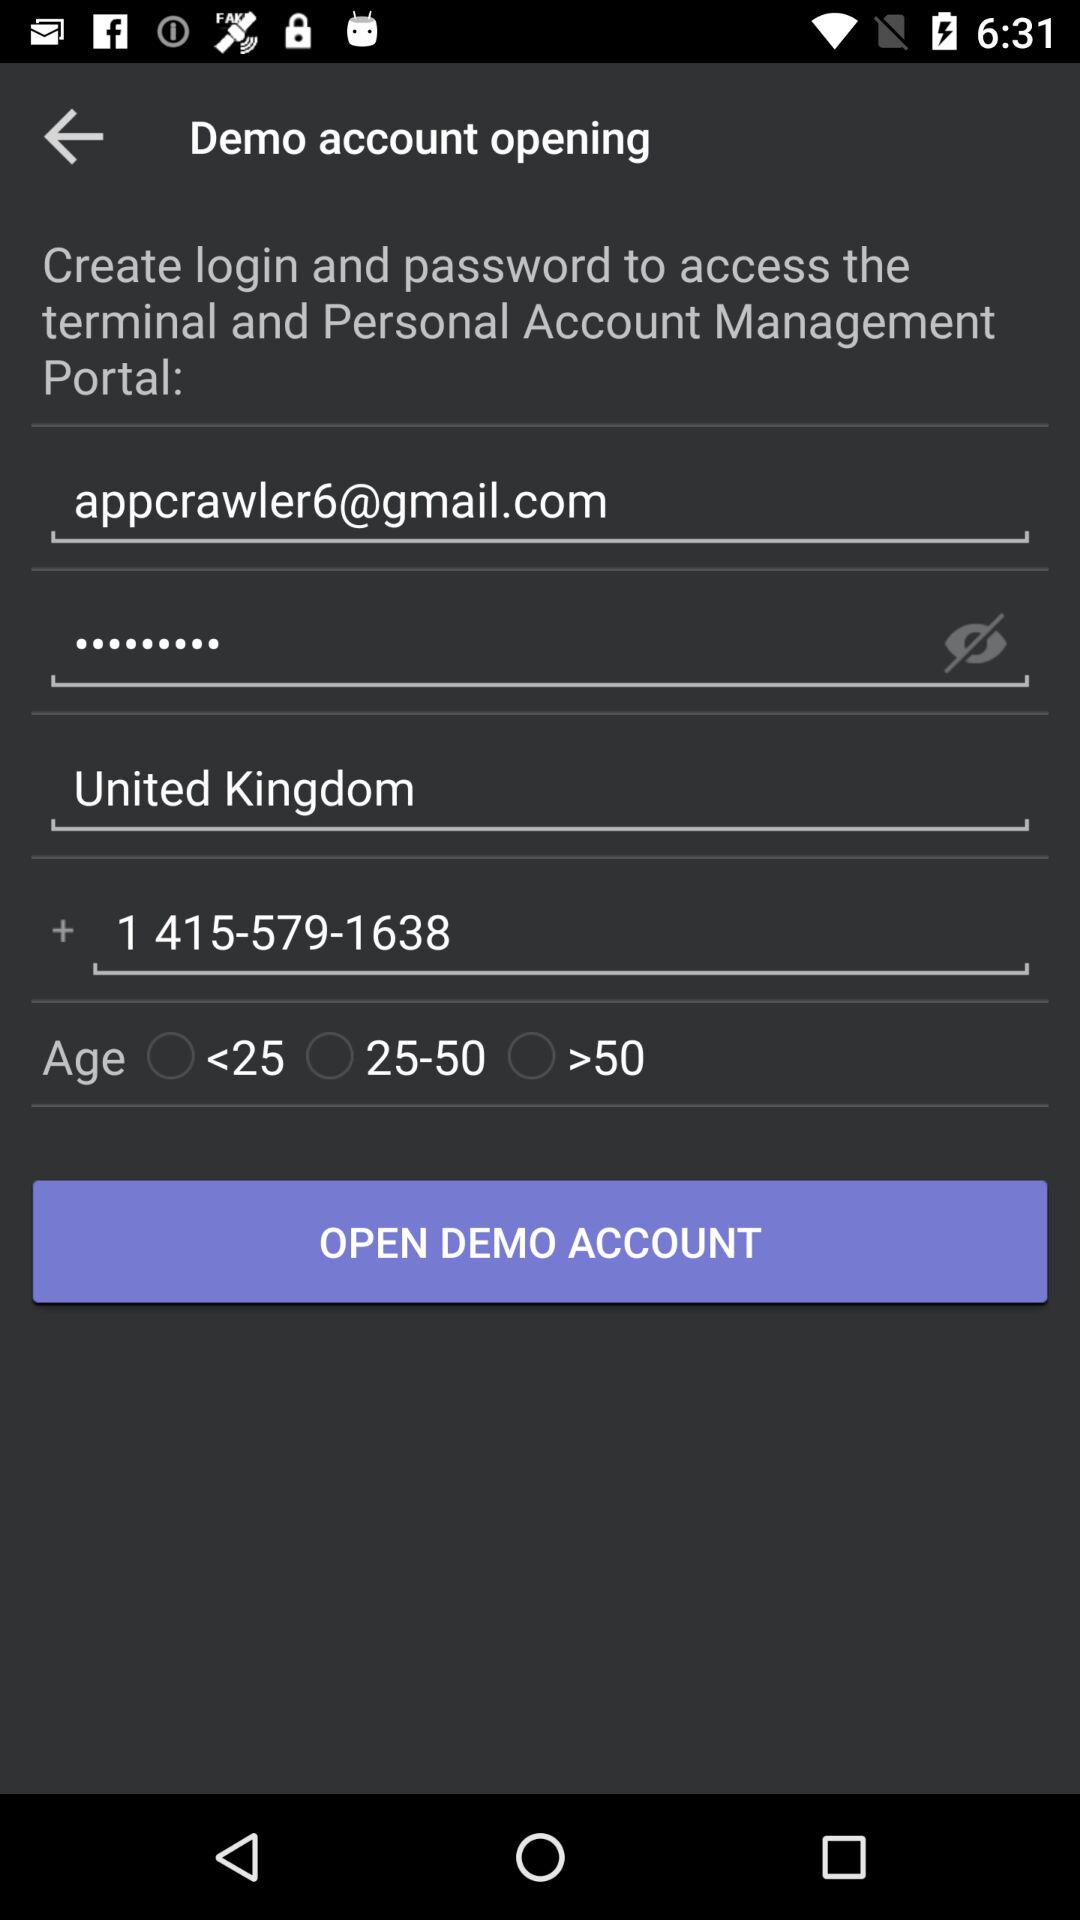What is the email address? The email address is appcrawler6@gmail.com. 